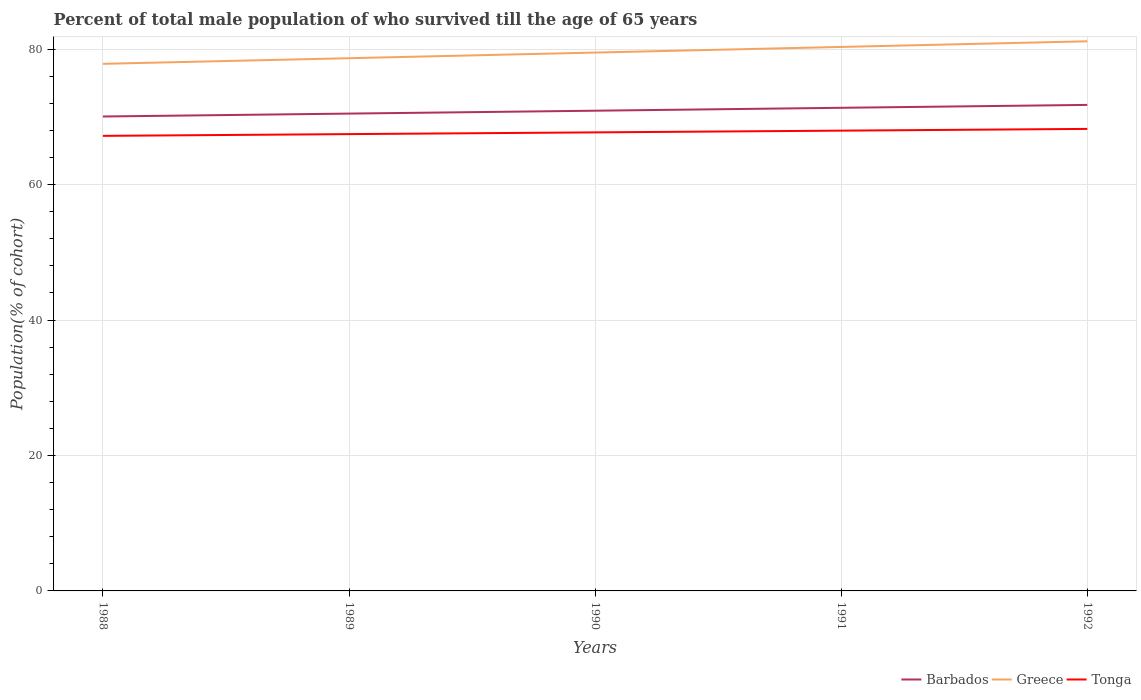How many different coloured lines are there?
Make the answer very short. 3. Is the number of lines equal to the number of legend labels?
Offer a very short reply. Yes. Across all years, what is the maximum percentage of total male population who survived till the age of 65 years in Barbados?
Give a very brief answer. 70.06. In which year was the percentage of total male population who survived till the age of 65 years in Tonga maximum?
Your answer should be compact. 1988. What is the total percentage of total male population who survived till the age of 65 years in Barbados in the graph?
Offer a terse response. -1.71. What is the difference between the highest and the second highest percentage of total male population who survived till the age of 65 years in Barbados?
Your answer should be compact. 1.71. What is the difference between the highest and the lowest percentage of total male population who survived till the age of 65 years in Barbados?
Ensure brevity in your answer.  3. Is the percentage of total male population who survived till the age of 65 years in Tonga strictly greater than the percentage of total male population who survived till the age of 65 years in Greece over the years?
Your answer should be very brief. Yes. How many years are there in the graph?
Keep it short and to the point. 5. Does the graph contain any zero values?
Give a very brief answer. No. Does the graph contain grids?
Your answer should be very brief. Yes. What is the title of the graph?
Offer a very short reply. Percent of total male population of who survived till the age of 65 years. What is the label or title of the X-axis?
Provide a succinct answer. Years. What is the label or title of the Y-axis?
Keep it short and to the point. Population(% of cohort). What is the Population(% of cohort) in Barbados in 1988?
Offer a very short reply. 70.06. What is the Population(% of cohort) in Greece in 1988?
Offer a very short reply. 77.84. What is the Population(% of cohort) in Tonga in 1988?
Offer a terse response. 67.2. What is the Population(% of cohort) in Barbados in 1989?
Your answer should be very brief. 70.49. What is the Population(% of cohort) in Greece in 1989?
Your answer should be very brief. 78.67. What is the Population(% of cohort) in Tonga in 1989?
Make the answer very short. 67.46. What is the Population(% of cohort) in Barbados in 1990?
Give a very brief answer. 70.92. What is the Population(% of cohort) of Greece in 1990?
Your response must be concise. 79.5. What is the Population(% of cohort) of Tonga in 1990?
Offer a terse response. 67.71. What is the Population(% of cohort) in Barbados in 1991?
Your response must be concise. 71.34. What is the Population(% of cohort) in Greece in 1991?
Provide a short and direct response. 80.33. What is the Population(% of cohort) in Tonga in 1991?
Ensure brevity in your answer.  67.97. What is the Population(% of cohort) of Barbados in 1992?
Provide a short and direct response. 71.77. What is the Population(% of cohort) of Greece in 1992?
Offer a very short reply. 81.16. What is the Population(% of cohort) of Tonga in 1992?
Your response must be concise. 68.23. Across all years, what is the maximum Population(% of cohort) in Barbados?
Your answer should be very brief. 71.77. Across all years, what is the maximum Population(% of cohort) in Greece?
Provide a succinct answer. 81.16. Across all years, what is the maximum Population(% of cohort) in Tonga?
Offer a terse response. 68.23. Across all years, what is the minimum Population(% of cohort) of Barbados?
Provide a succinct answer. 70.06. Across all years, what is the minimum Population(% of cohort) of Greece?
Your response must be concise. 77.84. Across all years, what is the minimum Population(% of cohort) of Tonga?
Keep it short and to the point. 67.2. What is the total Population(% of cohort) of Barbados in the graph?
Keep it short and to the point. 354.58. What is the total Population(% of cohort) of Greece in the graph?
Offer a very short reply. 397.5. What is the total Population(% of cohort) of Tonga in the graph?
Offer a terse response. 338.57. What is the difference between the Population(% of cohort) in Barbados in 1988 and that in 1989?
Make the answer very short. -0.43. What is the difference between the Population(% of cohort) in Greece in 1988 and that in 1989?
Your response must be concise. -0.83. What is the difference between the Population(% of cohort) in Tonga in 1988 and that in 1989?
Offer a very short reply. -0.26. What is the difference between the Population(% of cohort) in Barbados in 1988 and that in 1990?
Offer a very short reply. -0.86. What is the difference between the Population(% of cohort) of Greece in 1988 and that in 1990?
Keep it short and to the point. -1.66. What is the difference between the Population(% of cohort) in Tonga in 1988 and that in 1990?
Give a very brief answer. -0.51. What is the difference between the Population(% of cohort) in Barbados in 1988 and that in 1991?
Provide a succinct answer. -1.28. What is the difference between the Population(% of cohort) of Greece in 1988 and that in 1991?
Offer a very short reply. -2.5. What is the difference between the Population(% of cohort) of Tonga in 1988 and that in 1991?
Keep it short and to the point. -0.77. What is the difference between the Population(% of cohort) in Barbados in 1988 and that in 1992?
Your response must be concise. -1.71. What is the difference between the Population(% of cohort) in Greece in 1988 and that in 1992?
Give a very brief answer. -3.33. What is the difference between the Population(% of cohort) of Tonga in 1988 and that in 1992?
Provide a succinct answer. -1.03. What is the difference between the Population(% of cohort) in Barbados in 1989 and that in 1990?
Make the answer very short. -0.43. What is the difference between the Population(% of cohort) in Greece in 1989 and that in 1990?
Give a very brief answer. -0.83. What is the difference between the Population(% of cohort) in Tonga in 1989 and that in 1990?
Your answer should be compact. -0.26. What is the difference between the Population(% of cohort) of Barbados in 1989 and that in 1991?
Your answer should be compact. -0.86. What is the difference between the Population(% of cohort) in Greece in 1989 and that in 1991?
Your answer should be compact. -1.66. What is the difference between the Population(% of cohort) of Tonga in 1989 and that in 1991?
Your answer should be very brief. -0.51. What is the difference between the Population(% of cohort) in Barbados in 1989 and that in 1992?
Ensure brevity in your answer.  -1.28. What is the difference between the Population(% of cohort) of Greece in 1989 and that in 1992?
Your response must be concise. -2.5. What is the difference between the Population(% of cohort) of Tonga in 1989 and that in 1992?
Provide a succinct answer. -0.77. What is the difference between the Population(% of cohort) of Barbados in 1990 and that in 1991?
Your answer should be compact. -0.43. What is the difference between the Population(% of cohort) in Greece in 1990 and that in 1991?
Ensure brevity in your answer.  -0.83. What is the difference between the Population(% of cohort) in Tonga in 1990 and that in 1991?
Provide a succinct answer. -0.26. What is the difference between the Population(% of cohort) of Barbados in 1990 and that in 1992?
Your response must be concise. -0.86. What is the difference between the Population(% of cohort) of Greece in 1990 and that in 1992?
Offer a terse response. -1.66. What is the difference between the Population(% of cohort) in Tonga in 1990 and that in 1992?
Offer a terse response. -0.51. What is the difference between the Population(% of cohort) in Barbados in 1991 and that in 1992?
Make the answer very short. -0.43. What is the difference between the Population(% of cohort) of Greece in 1991 and that in 1992?
Ensure brevity in your answer.  -0.83. What is the difference between the Population(% of cohort) of Tonga in 1991 and that in 1992?
Make the answer very short. -0.26. What is the difference between the Population(% of cohort) in Barbados in 1988 and the Population(% of cohort) in Greece in 1989?
Offer a terse response. -8.61. What is the difference between the Population(% of cohort) in Barbados in 1988 and the Population(% of cohort) in Tonga in 1989?
Provide a succinct answer. 2.6. What is the difference between the Population(% of cohort) of Greece in 1988 and the Population(% of cohort) of Tonga in 1989?
Make the answer very short. 10.38. What is the difference between the Population(% of cohort) of Barbados in 1988 and the Population(% of cohort) of Greece in 1990?
Offer a terse response. -9.44. What is the difference between the Population(% of cohort) of Barbados in 1988 and the Population(% of cohort) of Tonga in 1990?
Your answer should be very brief. 2.35. What is the difference between the Population(% of cohort) of Greece in 1988 and the Population(% of cohort) of Tonga in 1990?
Offer a terse response. 10.12. What is the difference between the Population(% of cohort) in Barbados in 1988 and the Population(% of cohort) in Greece in 1991?
Ensure brevity in your answer.  -10.27. What is the difference between the Population(% of cohort) of Barbados in 1988 and the Population(% of cohort) of Tonga in 1991?
Your response must be concise. 2.09. What is the difference between the Population(% of cohort) in Greece in 1988 and the Population(% of cohort) in Tonga in 1991?
Your answer should be very brief. 9.87. What is the difference between the Population(% of cohort) in Barbados in 1988 and the Population(% of cohort) in Greece in 1992?
Your response must be concise. -11.1. What is the difference between the Population(% of cohort) of Barbados in 1988 and the Population(% of cohort) of Tonga in 1992?
Provide a succinct answer. 1.83. What is the difference between the Population(% of cohort) of Greece in 1988 and the Population(% of cohort) of Tonga in 1992?
Your answer should be very brief. 9.61. What is the difference between the Population(% of cohort) in Barbados in 1989 and the Population(% of cohort) in Greece in 1990?
Provide a short and direct response. -9.01. What is the difference between the Population(% of cohort) of Barbados in 1989 and the Population(% of cohort) of Tonga in 1990?
Keep it short and to the point. 2.77. What is the difference between the Population(% of cohort) in Greece in 1989 and the Population(% of cohort) in Tonga in 1990?
Provide a short and direct response. 10.95. What is the difference between the Population(% of cohort) in Barbados in 1989 and the Population(% of cohort) in Greece in 1991?
Your answer should be compact. -9.84. What is the difference between the Population(% of cohort) of Barbados in 1989 and the Population(% of cohort) of Tonga in 1991?
Provide a succinct answer. 2.52. What is the difference between the Population(% of cohort) of Greece in 1989 and the Population(% of cohort) of Tonga in 1991?
Give a very brief answer. 10.7. What is the difference between the Population(% of cohort) in Barbados in 1989 and the Population(% of cohort) in Greece in 1992?
Provide a short and direct response. -10.68. What is the difference between the Population(% of cohort) in Barbados in 1989 and the Population(% of cohort) in Tonga in 1992?
Provide a succinct answer. 2.26. What is the difference between the Population(% of cohort) in Greece in 1989 and the Population(% of cohort) in Tonga in 1992?
Provide a short and direct response. 10.44. What is the difference between the Population(% of cohort) of Barbados in 1990 and the Population(% of cohort) of Greece in 1991?
Ensure brevity in your answer.  -9.42. What is the difference between the Population(% of cohort) in Barbados in 1990 and the Population(% of cohort) in Tonga in 1991?
Make the answer very short. 2.94. What is the difference between the Population(% of cohort) in Greece in 1990 and the Population(% of cohort) in Tonga in 1991?
Ensure brevity in your answer.  11.53. What is the difference between the Population(% of cohort) of Barbados in 1990 and the Population(% of cohort) of Greece in 1992?
Your answer should be compact. -10.25. What is the difference between the Population(% of cohort) in Barbados in 1990 and the Population(% of cohort) in Tonga in 1992?
Provide a succinct answer. 2.69. What is the difference between the Population(% of cohort) of Greece in 1990 and the Population(% of cohort) of Tonga in 1992?
Keep it short and to the point. 11.27. What is the difference between the Population(% of cohort) in Barbados in 1991 and the Population(% of cohort) in Greece in 1992?
Offer a very short reply. -9.82. What is the difference between the Population(% of cohort) in Barbados in 1991 and the Population(% of cohort) in Tonga in 1992?
Offer a very short reply. 3.12. What is the difference between the Population(% of cohort) of Greece in 1991 and the Population(% of cohort) of Tonga in 1992?
Provide a short and direct response. 12.1. What is the average Population(% of cohort) in Barbados per year?
Your answer should be compact. 70.92. What is the average Population(% of cohort) of Greece per year?
Your answer should be very brief. 79.5. What is the average Population(% of cohort) of Tonga per year?
Offer a terse response. 67.71. In the year 1988, what is the difference between the Population(% of cohort) in Barbados and Population(% of cohort) in Greece?
Your response must be concise. -7.78. In the year 1988, what is the difference between the Population(% of cohort) in Barbados and Population(% of cohort) in Tonga?
Offer a very short reply. 2.86. In the year 1988, what is the difference between the Population(% of cohort) in Greece and Population(% of cohort) in Tonga?
Keep it short and to the point. 10.63. In the year 1989, what is the difference between the Population(% of cohort) in Barbados and Population(% of cohort) in Greece?
Offer a very short reply. -8.18. In the year 1989, what is the difference between the Population(% of cohort) of Barbados and Population(% of cohort) of Tonga?
Your answer should be compact. 3.03. In the year 1989, what is the difference between the Population(% of cohort) of Greece and Population(% of cohort) of Tonga?
Provide a succinct answer. 11.21. In the year 1990, what is the difference between the Population(% of cohort) of Barbados and Population(% of cohort) of Greece?
Give a very brief answer. -8.58. In the year 1990, what is the difference between the Population(% of cohort) of Barbados and Population(% of cohort) of Tonga?
Keep it short and to the point. 3.2. In the year 1990, what is the difference between the Population(% of cohort) of Greece and Population(% of cohort) of Tonga?
Your answer should be very brief. 11.79. In the year 1991, what is the difference between the Population(% of cohort) of Barbados and Population(% of cohort) of Greece?
Your response must be concise. -8.99. In the year 1991, what is the difference between the Population(% of cohort) of Barbados and Population(% of cohort) of Tonga?
Make the answer very short. 3.37. In the year 1991, what is the difference between the Population(% of cohort) of Greece and Population(% of cohort) of Tonga?
Keep it short and to the point. 12.36. In the year 1992, what is the difference between the Population(% of cohort) of Barbados and Population(% of cohort) of Greece?
Give a very brief answer. -9.39. In the year 1992, what is the difference between the Population(% of cohort) in Barbados and Population(% of cohort) in Tonga?
Your answer should be very brief. 3.54. In the year 1992, what is the difference between the Population(% of cohort) in Greece and Population(% of cohort) in Tonga?
Keep it short and to the point. 12.94. What is the ratio of the Population(% of cohort) of Barbados in 1988 to that in 1989?
Provide a succinct answer. 0.99. What is the ratio of the Population(% of cohort) of Greece in 1988 to that in 1989?
Keep it short and to the point. 0.99. What is the ratio of the Population(% of cohort) of Barbados in 1988 to that in 1990?
Provide a short and direct response. 0.99. What is the ratio of the Population(% of cohort) in Greece in 1988 to that in 1990?
Ensure brevity in your answer.  0.98. What is the ratio of the Population(% of cohort) of Barbados in 1988 to that in 1991?
Your response must be concise. 0.98. What is the ratio of the Population(% of cohort) in Greece in 1988 to that in 1991?
Make the answer very short. 0.97. What is the ratio of the Population(% of cohort) in Tonga in 1988 to that in 1991?
Your answer should be very brief. 0.99. What is the ratio of the Population(% of cohort) of Barbados in 1988 to that in 1992?
Give a very brief answer. 0.98. What is the ratio of the Population(% of cohort) in Tonga in 1988 to that in 1992?
Offer a terse response. 0.98. What is the ratio of the Population(% of cohort) in Greece in 1989 to that in 1990?
Your response must be concise. 0.99. What is the ratio of the Population(% of cohort) of Greece in 1989 to that in 1991?
Give a very brief answer. 0.98. What is the ratio of the Population(% of cohort) in Barbados in 1989 to that in 1992?
Offer a terse response. 0.98. What is the ratio of the Population(% of cohort) of Greece in 1989 to that in 1992?
Offer a terse response. 0.97. What is the ratio of the Population(% of cohort) in Tonga in 1989 to that in 1992?
Keep it short and to the point. 0.99. What is the ratio of the Population(% of cohort) in Barbados in 1990 to that in 1991?
Provide a succinct answer. 0.99. What is the ratio of the Population(% of cohort) of Tonga in 1990 to that in 1991?
Your response must be concise. 1. What is the ratio of the Population(% of cohort) of Greece in 1990 to that in 1992?
Offer a very short reply. 0.98. What is the ratio of the Population(% of cohort) in Tonga in 1990 to that in 1992?
Make the answer very short. 0.99. What is the ratio of the Population(% of cohort) in Tonga in 1991 to that in 1992?
Make the answer very short. 1. What is the difference between the highest and the second highest Population(% of cohort) in Barbados?
Offer a terse response. 0.43. What is the difference between the highest and the second highest Population(% of cohort) of Greece?
Provide a short and direct response. 0.83. What is the difference between the highest and the second highest Population(% of cohort) of Tonga?
Offer a very short reply. 0.26. What is the difference between the highest and the lowest Population(% of cohort) in Barbados?
Your response must be concise. 1.71. What is the difference between the highest and the lowest Population(% of cohort) in Greece?
Offer a very short reply. 3.33. What is the difference between the highest and the lowest Population(% of cohort) of Tonga?
Offer a terse response. 1.03. 